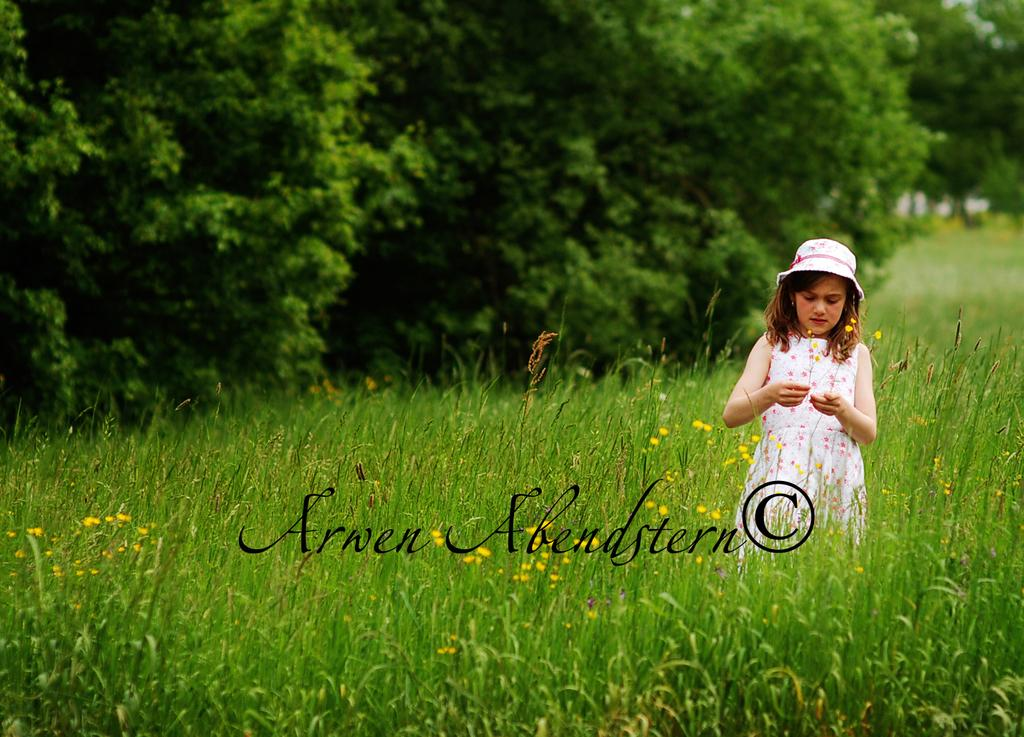Who is present in the image? There is a woman in the image. What is the woman doing in the image? The woman is standing in the image. What is the woman wearing on her head? The woman is wearing a hat in the image. What color is the woman's dress? The woman is wearing a white dress in the image. What can be seen in the background of the image? There are trees and plants in the background of the image. Is there any additional information about the image? Yes, there is a watermark in the image. What type of humor is the woman displaying in the image? There is no indication of humor in the image; the woman is simply standing and wearing a hat and white dress. In which direction is the woman facing in the image? The provided facts do not specify the direction the woman is facing in the image. 